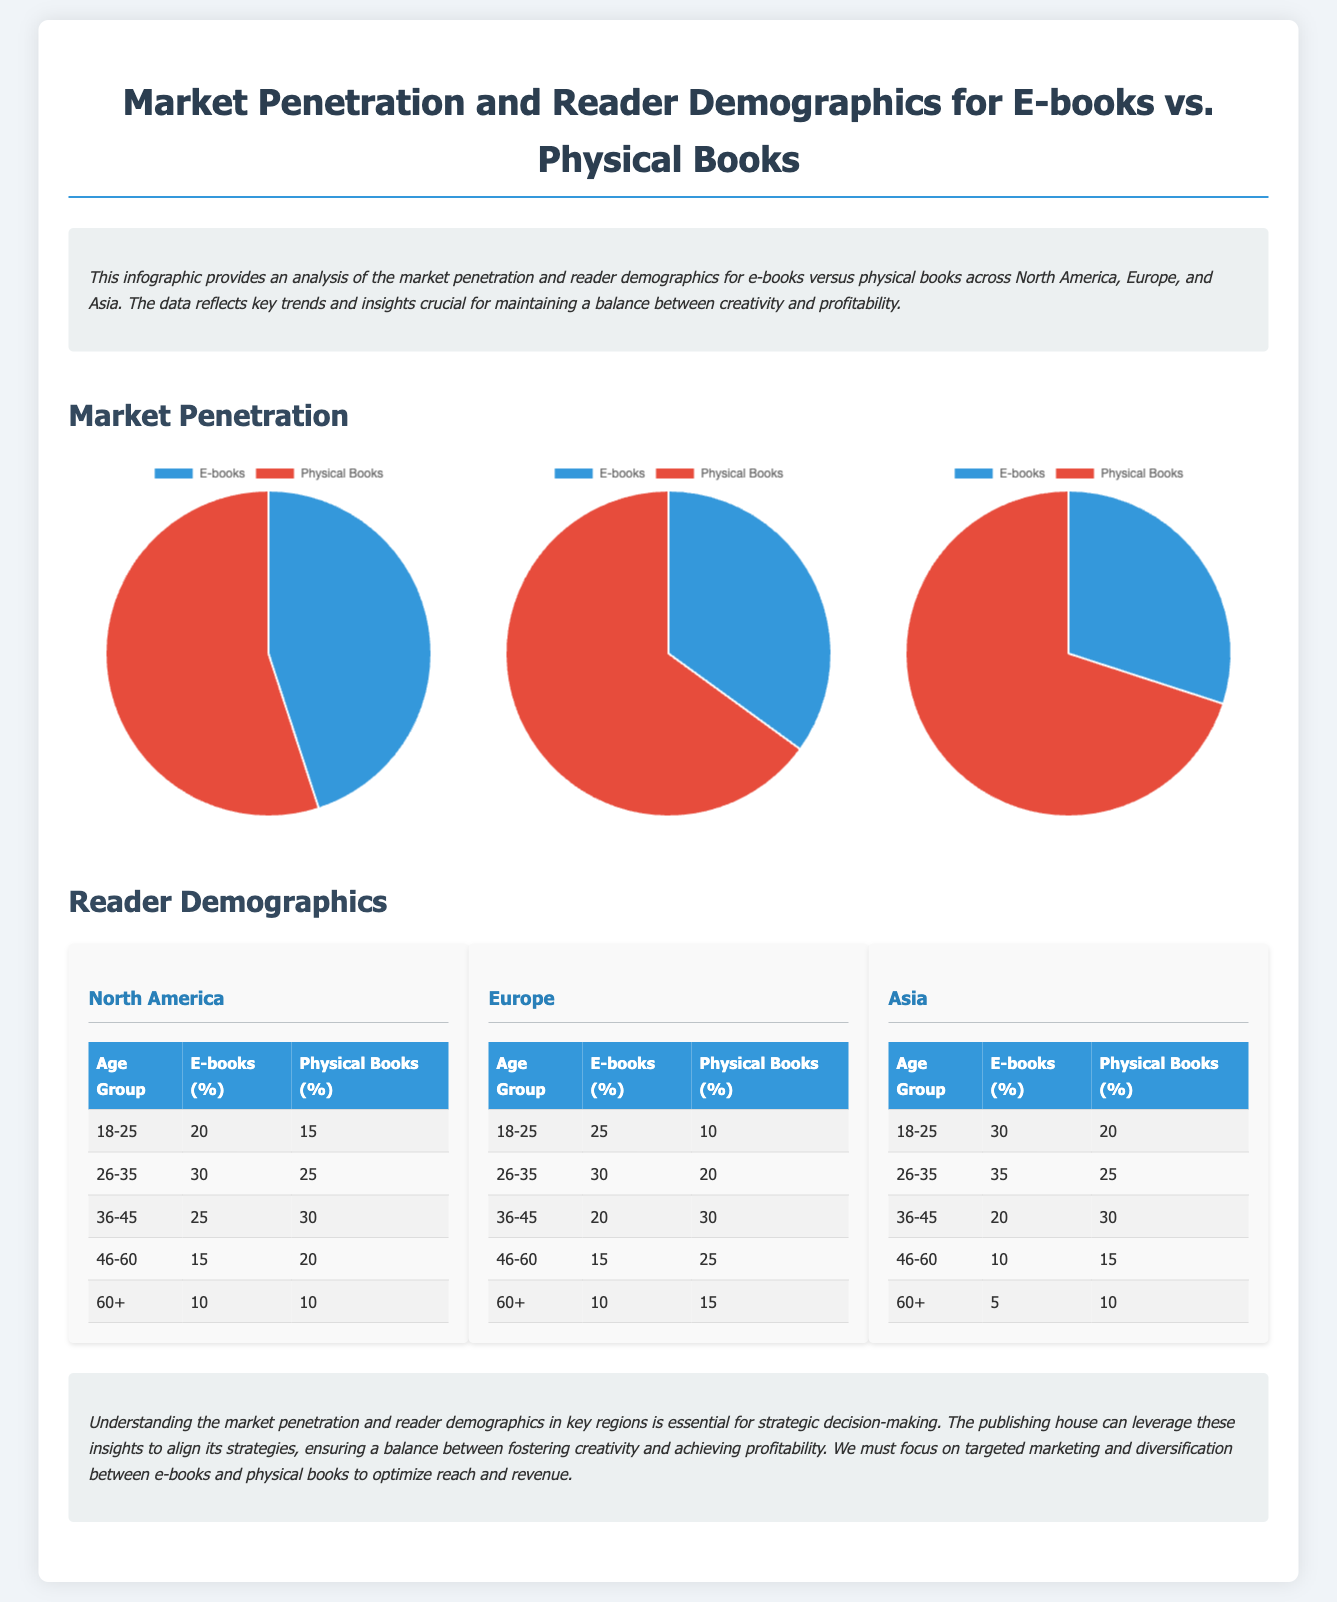What percentage of readers aged 18-25 in North America read E-books? The document states that 20% of readers aged 18-25 in North America read E-books.
Answer: 20% What is the market penetration of E-books in Europe? The document shows that E-books have a market penetration of 35% in Europe.
Answer: 35% Which age group has the highest percentage of E-book readers in Asia? The demographics table indicates that the age group 26-35 has the highest percentage of E-book readers in Asia at 35%.
Answer: 35% How many percent of readers aged 46-60 in Europe read physical books? The document provides that 25% of readers aged 46-60 in Europe read physical books.
Answer: 25% What is the ratio of E-book readers to Physical book readers in North America? The market penetration indicates that for every 45 E-book readers, there are 55 Physical book readers in North America, giving a ratio of 45:55.
Answer: 45:55 Which region has the lowest E-book penetration? Based on the pie charts, Asia has the lowest E-book penetration at 30%.
Answer: Asia What is the percentage of Physical book readers aged 36-45 in North America? The document specifies that 30% of readers aged 36-45 in North America read Physical books.
Answer: 30% What demographic group has the smallest percentage of E-book readership in Europe? The demographics table indicates that the age group 60+ has the smallest percentage of E-book readership in Europe at 10%.
Answer: 10% 